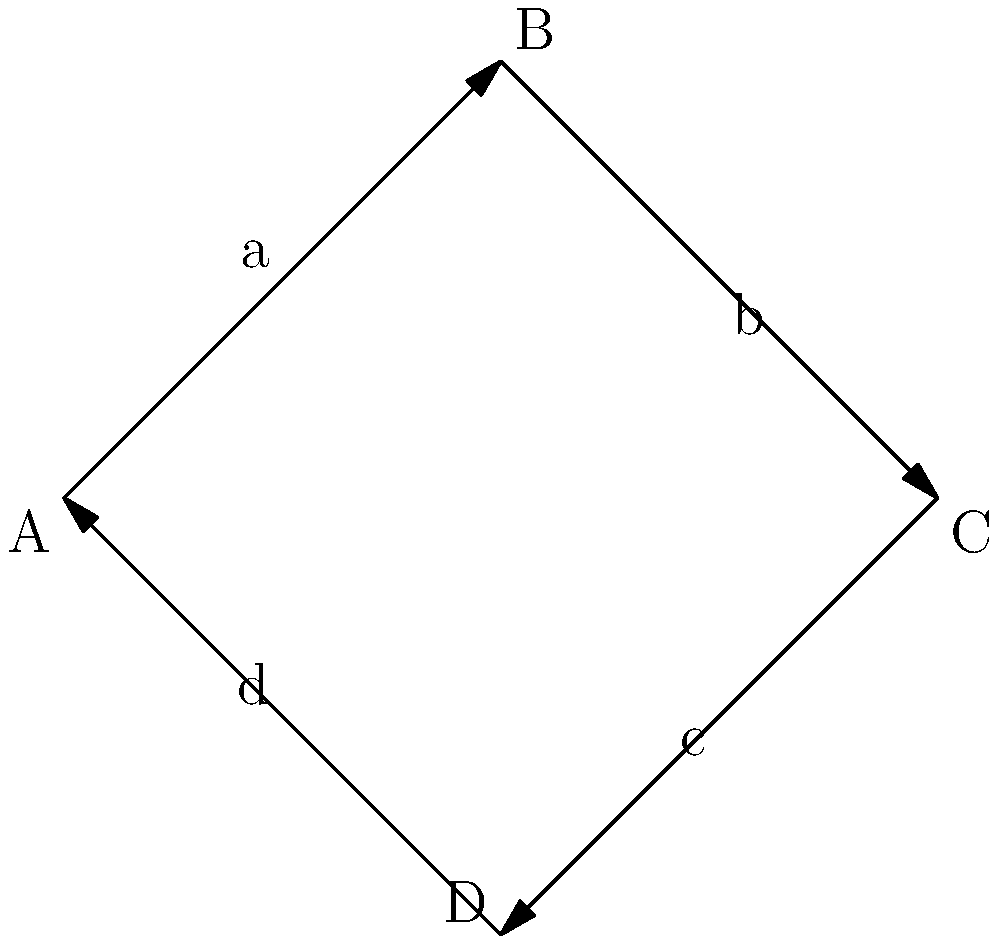In underground hip-hop production, we often use Cayley graphs to visualize song structures. Consider the Cayley graph above representing a 4-bar loop in a track. If each edge represents a unique sample (a, b, c, d) and each vertex represents a beat, what is the group presentation for this song structure, assuming the identity element is vertex A? To find the group presentation for this song structure, we need to follow these steps:

1. Identify the generators: The generators are the labeled edges (a, b, c, d).

2. Determine the relations:
   - Starting from A and following 'a', we reach B.
   - From B, following 'b' leads to C.
   - From C, 'c' takes us to D.
   - From D, 'd' brings us back to A.

3. Express these as equations:
   $a = B$
   $ab = C$
   $abc = D$
   $abcd = A$ (identity)

4. The last equation gives us the primary relation: $abcd = e$ (where e is the identity element)

5. We also need to consider the order of each generator. In this case, each generator appears only once in the cycle, so they all have order 4:
   $a^4 = b^4 = c^4 = d^4 = e$

6. The group presentation is written as:
   $$\langle a, b, c, d \mid abcd = a^4 = b^4 = c^4 = d^4 = e \rangle$$

This presentation describes a group isomorphic to the cyclic group of order 4, $C_4$, which corresponds to the 4-bar loop structure of the track.
Answer: $\langle a, b, c, d \mid abcd = a^4 = b^4 = c^4 = d^4 = e \rangle$ 